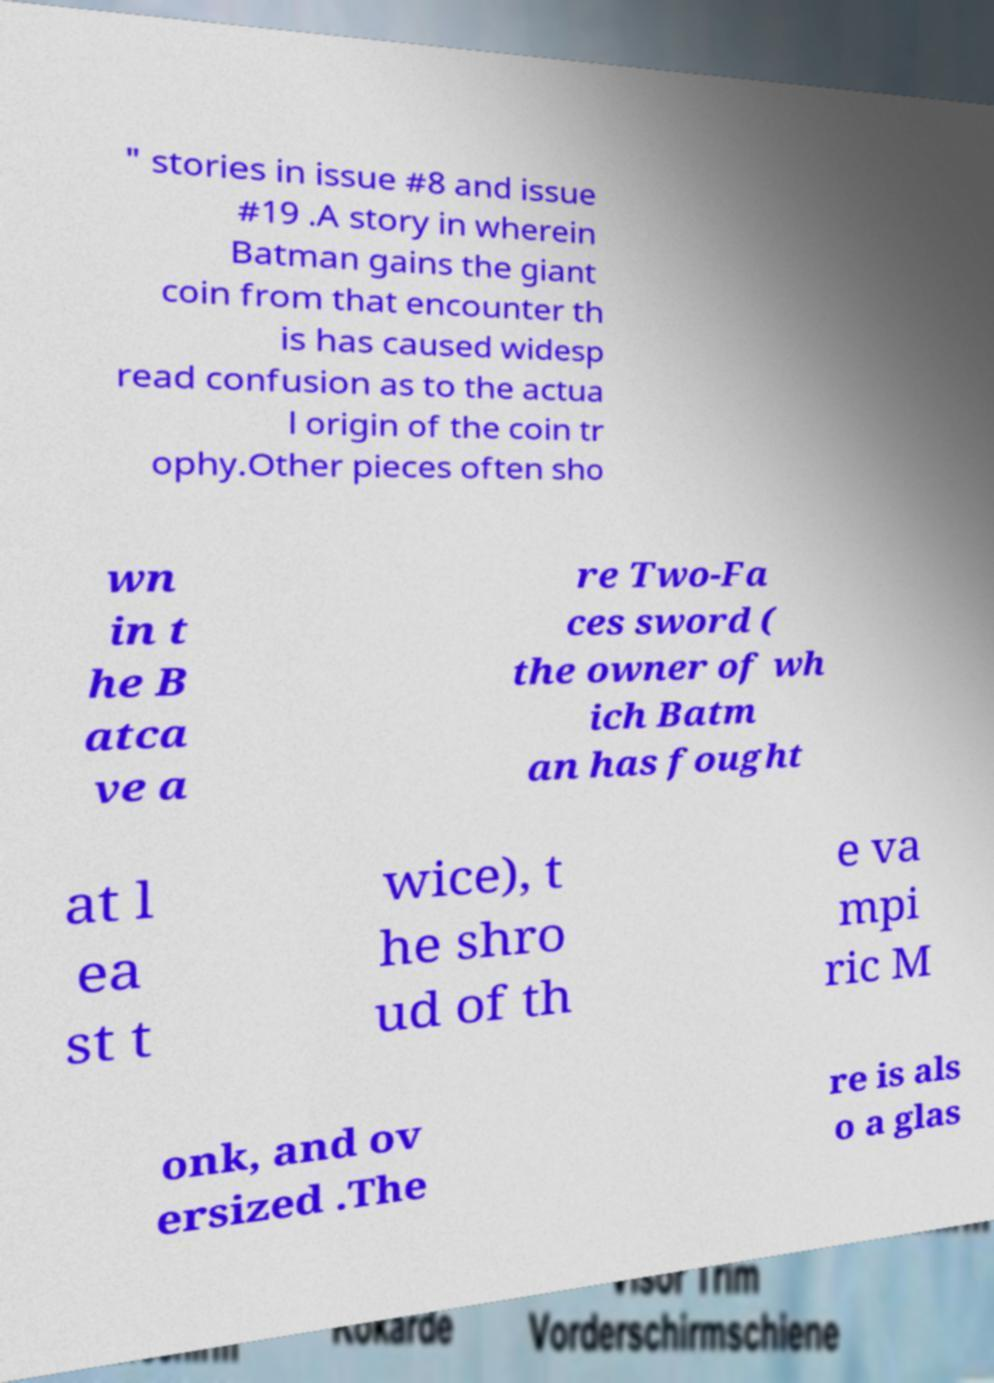What messages or text are displayed in this image? I need them in a readable, typed format. " stories in issue #8 and issue #19 .A story in wherein Batman gains the giant coin from that encounter th is has caused widesp read confusion as to the actua l origin of the coin tr ophy.Other pieces often sho wn in t he B atca ve a re Two-Fa ces sword ( the owner of wh ich Batm an has fought at l ea st t wice), t he shro ud of th e va mpi ric M onk, and ov ersized .The re is als o a glas 